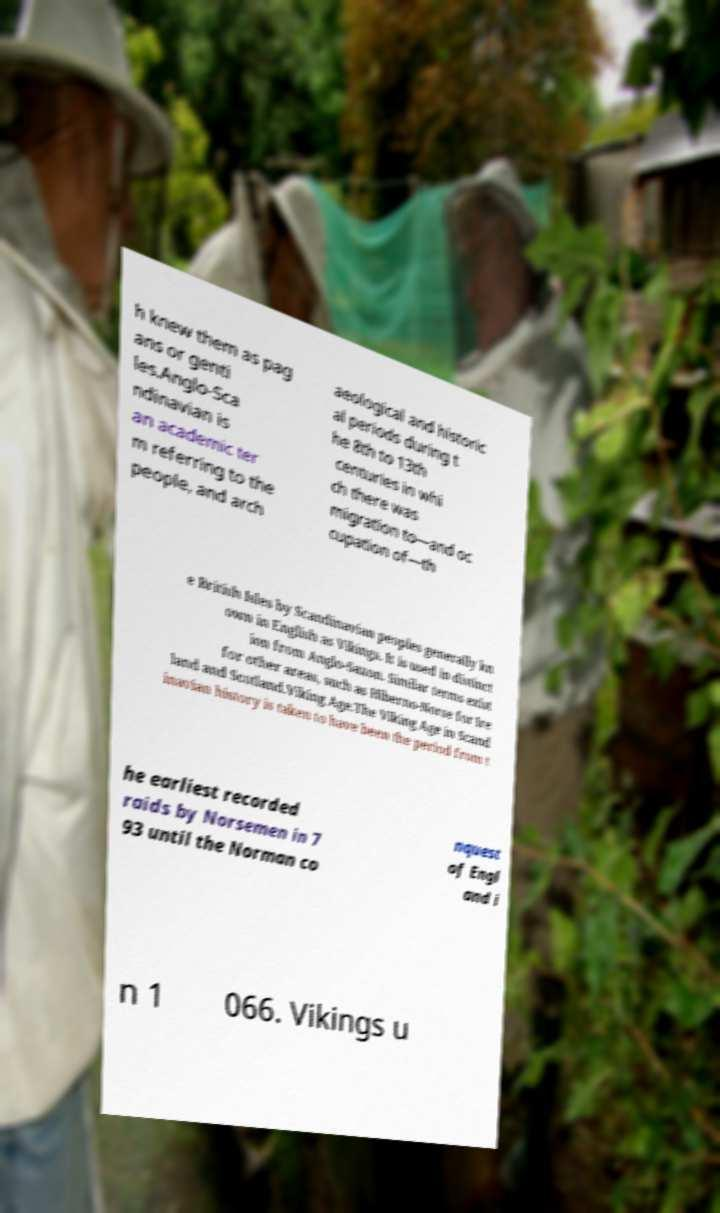Could you assist in decoding the text presented in this image and type it out clearly? h knew them as pag ans or genti les.Anglo-Sca ndinavian is an academic ter m referring to the people, and arch aeological and historic al periods during t he 8th to 13th centuries in whi ch there was migration to—and oc cupation of—th e British Isles by Scandinavian peoples generally kn own in English as Vikings. It is used in distinct ion from Anglo-Saxon. Similar terms exist for other areas, such as Hiberno-Norse for Ire land and Scotland.Viking Age.The Viking Age in Scand inavian history is taken to have been the period from t he earliest recorded raids by Norsemen in 7 93 until the Norman co nquest of Engl and i n 1 066. Vikings u 